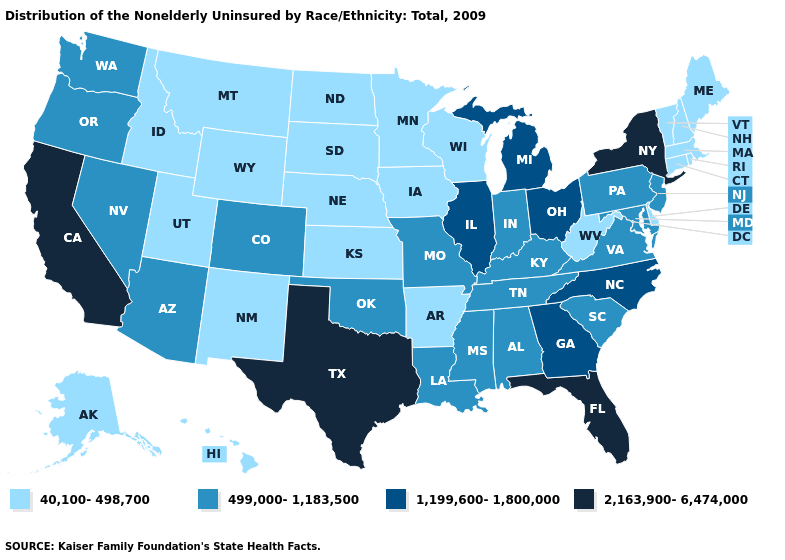What is the value of Florida?
Write a very short answer. 2,163,900-6,474,000. What is the lowest value in the USA?
Write a very short answer. 40,100-498,700. What is the highest value in states that border Rhode Island?
Quick response, please. 40,100-498,700. What is the value of Minnesota?
Concise answer only. 40,100-498,700. What is the value of Iowa?
Keep it brief. 40,100-498,700. What is the highest value in the MidWest ?
Concise answer only. 1,199,600-1,800,000. Does the first symbol in the legend represent the smallest category?
Answer briefly. Yes. What is the value of Massachusetts?
Short answer required. 40,100-498,700. Name the states that have a value in the range 1,199,600-1,800,000?
Write a very short answer. Georgia, Illinois, Michigan, North Carolina, Ohio. Does West Virginia have the lowest value in the South?
Give a very brief answer. Yes. Among the states that border Utah , does Idaho have the lowest value?
Keep it brief. Yes. Which states have the lowest value in the Northeast?
Be succinct. Connecticut, Maine, Massachusetts, New Hampshire, Rhode Island, Vermont. What is the highest value in the MidWest ?
Quick response, please. 1,199,600-1,800,000. What is the value of Massachusetts?
Concise answer only. 40,100-498,700. 